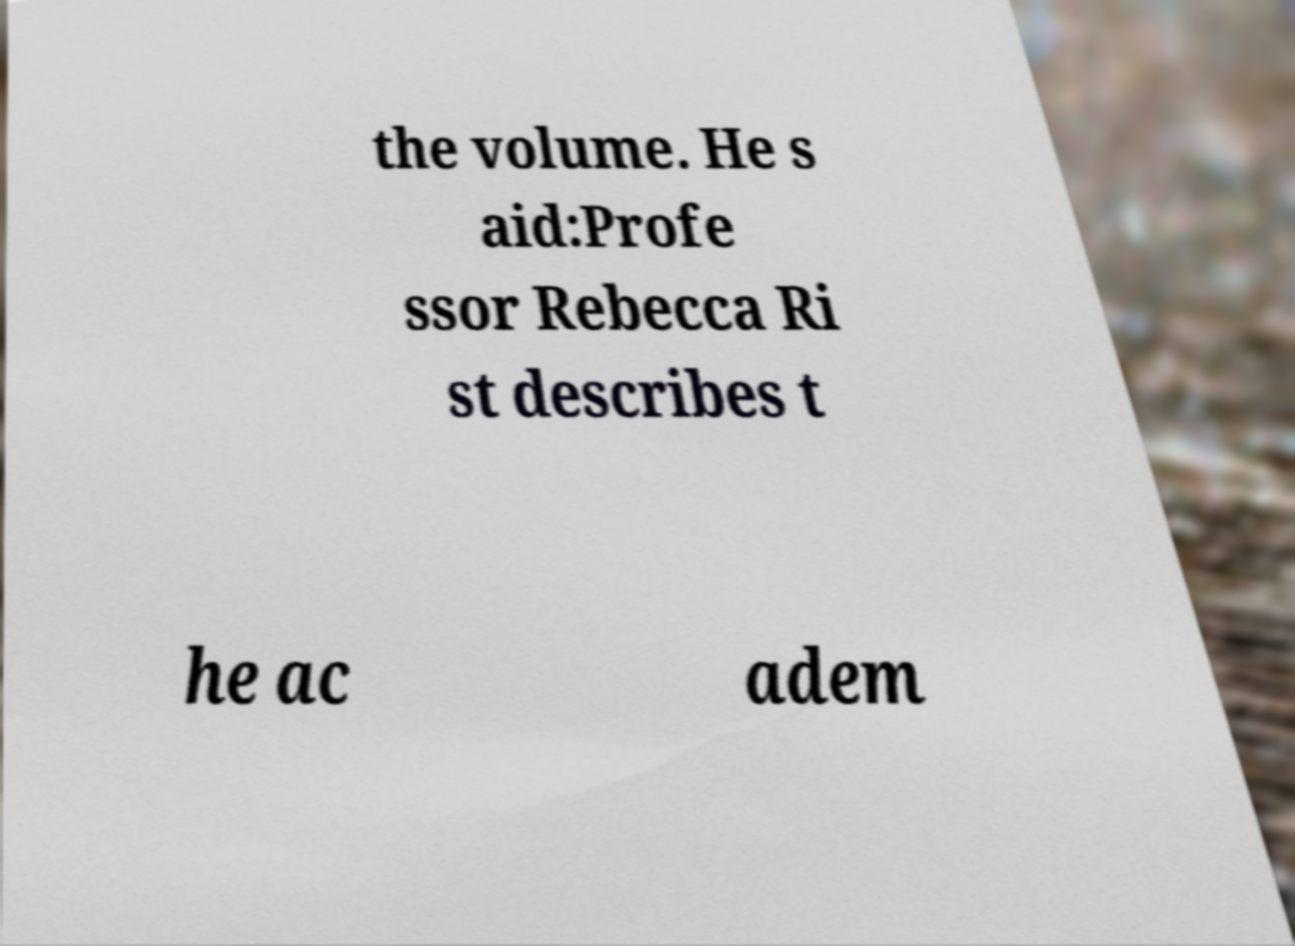Could you extract and type out the text from this image? the volume. He s aid:Profe ssor Rebecca Ri st describes t he ac adem 